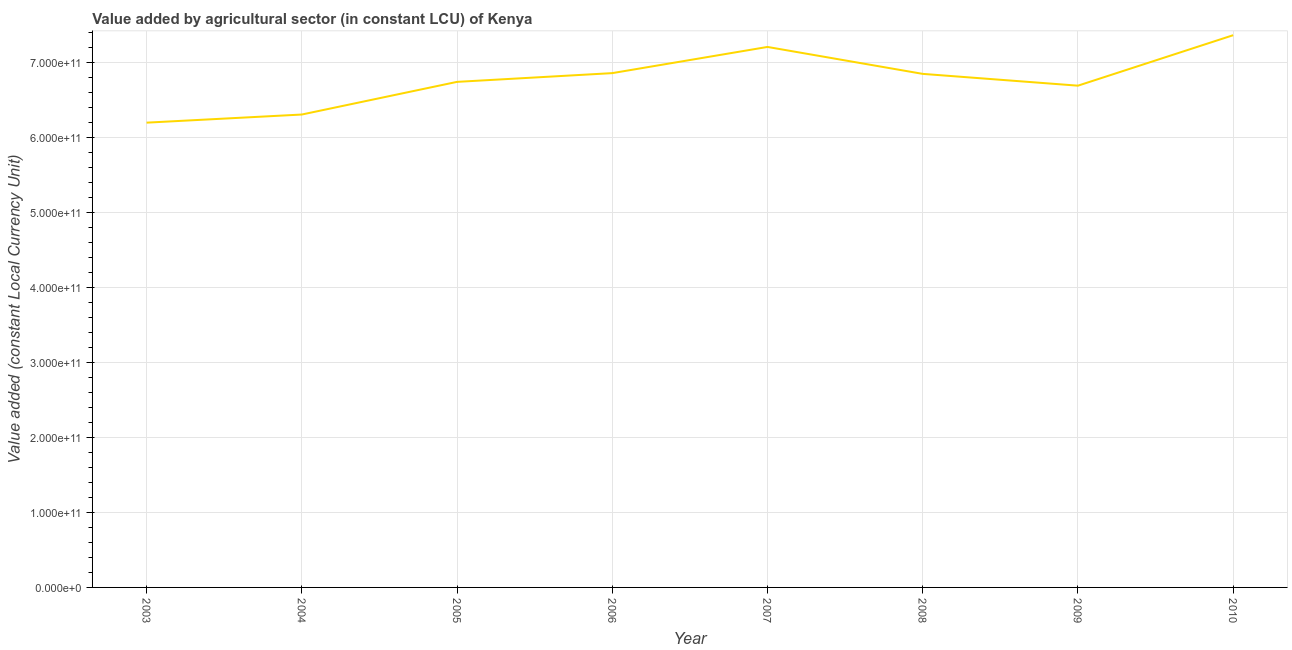What is the value added by agriculture sector in 2004?
Provide a short and direct response. 6.31e+11. Across all years, what is the maximum value added by agriculture sector?
Offer a very short reply. 7.36e+11. Across all years, what is the minimum value added by agriculture sector?
Provide a short and direct response. 6.20e+11. What is the sum of the value added by agriculture sector?
Give a very brief answer. 5.42e+12. What is the difference between the value added by agriculture sector in 2005 and 2008?
Make the answer very short. -1.07e+1. What is the average value added by agriculture sector per year?
Offer a terse response. 6.78e+11. What is the median value added by agriculture sector?
Give a very brief answer. 6.79e+11. What is the ratio of the value added by agriculture sector in 2004 to that in 2010?
Your response must be concise. 0.86. Is the value added by agriculture sector in 2005 less than that in 2007?
Your response must be concise. Yes. Is the difference between the value added by agriculture sector in 2008 and 2010 greater than the difference between any two years?
Keep it short and to the point. No. What is the difference between the highest and the second highest value added by agriculture sector?
Your answer should be very brief. 1.57e+1. What is the difference between the highest and the lowest value added by agriculture sector?
Offer a terse response. 1.17e+11. Does the value added by agriculture sector monotonically increase over the years?
Provide a short and direct response. No. What is the difference between two consecutive major ticks on the Y-axis?
Ensure brevity in your answer.  1.00e+11. What is the title of the graph?
Offer a terse response. Value added by agricultural sector (in constant LCU) of Kenya. What is the label or title of the X-axis?
Ensure brevity in your answer.  Year. What is the label or title of the Y-axis?
Provide a short and direct response. Value added (constant Local Currency Unit). What is the Value added (constant Local Currency Unit) in 2003?
Your answer should be compact. 6.20e+11. What is the Value added (constant Local Currency Unit) in 2004?
Your answer should be compact. 6.31e+11. What is the Value added (constant Local Currency Unit) in 2005?
Give a very brief answer. 6.74e+11. What is the Value added (constant Local Currency Unit) of 2006?
Offer a very short reply. 6.86e+11. What is the Value added (constant Local Currency Unit) of 2007?
Make the answer very short. 7.21e+11. What is the Value added (constant Local Currency Unit) of 2008?
Ensure brevity in your answer.  6.85e+11. What is the Value added (constant Local Currency Unit) in 2009?
Keep it short and to the point. 6.69e+11. What is the Value added (constant Local Currency Unit) of 2010?
Your answer should be compact. 7.36e+11. What is the difference between the Value added (constant Local Currency Unit) in 2003 and 2004?
Your answer should be compact. -1.08e+1. What is the difference between the Value added (constant Local Currency Unit) in 2003 and 2005?
Keep it short and to the point. -5.44e+1. What is the difference between the Value added (constant Local Currency Unit) in 2003 and 2006?
Your answer should be compact. -6.60e+1. What is the difference between the Value added (constant Local Currency Unit) in 2003 and 2007?
Your response must be concise. -1.01e+11. What is the difference between the Value added (constant Local Currency Unit) in 2003 and 2008?
Provide a short and direct response. -6.50e+1. What is the difference between the Value added (constant Local Currency Unit) in 2003 and 2009?
Your answer should be compact. -4.93e+1. What is the difference between the Value added (constant Local Currency Unit) in 2003 and 2010?
Make the answer very short. -1.17e+11. What is the difference between the Value added (constant Local Currency Unit) in 2004 and 2005?
Provide a succinct answer. -4.35e+1. What is the difference between the Value added (constant Local Currency Unit) in 2004 and 2006?
Keep it short and to the point. -5.52e+1. What is the difference between the Value added (constant Local Currency Unit) in 2004 and 2007?
Your answer should be very brief. -9.01e+1. What is the difference between the Value added (constant Local Currency Unit) in 2004 and 2008?
Your response must be concise. -5.42e+1. What is the difference between the Value added (constant Local Currency Unit) in 2004 and 2009?
Provide a succinct answer. -3.85e+1. What is the difference between the Value added (constant Local Currency Unit) in 2004 and 2010?
Your answer should be very brief. -1.06e+11. What is the difference between the Value added (constant Local Currency Unit) in 2005 and 2006?
Ensure brevity in your answer.  -1.17e+1. What is the difference between the Value added (constant Local Currency Unit) in 2005 and 2007?
Your answer should be compact. -4.66e+1. What is the difference between the Value added (constant Local Currency Unit) in 2005 and 2008?
Make the answer very short. -1.07e+1. What is the difference between the Value added (constant Local Currency Unit) in 2005 and 2009?
Ensure brevity in your answer.  5.08e+09. What is the difference between the Value added (constant Local Currency Unit) in 2005 and 2010?
Ensure brevity in your answer.  -6.22e+1. What is the difference between the Value added (constant Local Currency Unit) in 2006 and 2007?
Keep it short and to the point. -3.49e+1. What is the difference between the Value added (constant Local Currency Unit) in 2006 and 2008?
Make the answer very short. 1.01e+09. What is the difference between the Value added (constant Local Currency Unit) in 2006 and 2009?
Your answer should be compact. 1.67e+1. What is the difference between the Value added (constant Local Currency Unit) in 2006 and 2010?
Your answer should be compact. -5.06e+1. What is the difference between the Value added (constant Local Currency Unit) in 2007 and 2008?
Your answer should be compact. 3.59e+1. What is the difference between the Value added (constant Local Currency Unit) in 2007 and 2009?
Your answer should be very brief. 5.16e+1. What is the difference between the Value added (constant Local Currency Unit) in 2007 and 2010?
Offer a terse response. -1.57e+1. What is the difference between the Value added (constant Local Currency Unit) in 2008 and 2009?
Provide a succinct answer. 1.57e+1. What is the difference between the Value added (constant Local Currency Unit) in 2008 and 2010?
Your response must be concise. -5.16e+1. What is the difference between the Value added (constant Local Currency Unit) in 2009 and 2010?
Your response must be concise. -6.73e+1. What is the ratio of the Value added (constant Local Currency Unit) in 2003 to that in 2004?
Your answer should be very brief. 0.98. What is the ratio of the Value added (constant Local Currency Unit) in 2003 to that in 2005?
Your response must be concise. 0.92. What is the ratio of the Value added (constant Local Currency Unit) in 2003 to that in 2006?
Your answer should be very brief. 0.9. What is the ratio of the Value added (constant Local Currency Unit) in 2003 to that in 2007?
Your answer should be very brief. 0.86. What is the ratio of the Value added (constant Local Currency Unit) in 2003 to that in 2008?
Make the answer very short. 0.91. What is the ratio of the Value added (constant Local Currency Unit) in 2003 to that in 2009?
Ensure brevity in your answer.  0.93. What is the ratio of the Value added (constant Local Currency Unit) in 2003 to that in 2010?
Provide a short and direct response. 0.84. What is the ratio of the Value added (constant Local Currency Unit) in 2004 to that in 2005?
Your answer should be compact. 0.94. What is the ratio of the Value added (constant Local Currency Unit) in 2004 to that in 2006?
Offer a terse response. 0.92. What is the ratio of the Value added (constant Local Currency Unit) in 2004 to that in 2008?
Provide a succinct answer. 0.92. What is the ratio of the Value added (constant Local Currency Unit) in 2004 to that in 2009?
Ensure brevity in your answer.  0.94. What is the ratio of the Value added (constant Local Currency Unit) in 2004 to that in 2010?
Provide a succinct answer. 0.86. What is the ratio of the Value added (constant Local Currency Unit) in 2005 to that in 2006?
Ensure brevity in your answer.  0.98. What is the ratio of the Value added (constant Local Currency Unit) in 2005 to that in 2007?
Offer a terse response. 0.94. What is the ratio of the Value added (constant Local Currency Unit) in 2005 to that in 2008?
Your answer should be compact. 0.98. What is the ratio of the Value added (constant Local Currency Unit) in 2005 to that in 2009?
Offer a very short reply. 1.01. What is the ratio of the Value added (constant Local Currency Unit) in 2005 to that in 2010?
Give a very brief answer. 0.92. What is the ratio of the Value added (constant Local Currency Unit) in 2006 to that in 2008?
Provide a short and direct response. 1. What is the ratio of the Value added (constant Local Currency Unit) in 2006 to that in 2009?
Your response must be concise. 1.02. What is the ratio of the Value added (constant Local Currency Unit) in 2006 to that in 2010?
Make the answer very short. 0.93. What is the ratio of the Value added (constant Local Currency Unit) in 2007 to that in 2008?
Ensure brevity in your answer.  1.05. What is the ratio of the Value added (constant Local Currency Unit) in 2007 to that in 2009?
Your response must be concise. 1.08. What is the ratio of the Value added (constant Local Currency Unit) in 2007 to that in 2010?
Your answer should be very brief. 0.98. What is the ratio of the Value added (constant Local Currency Unit) in 2008 to that in 2009?
Provide a succinct answer. 1.02. What is the ratio of the Value added (constant Local Currency Unit) in 2009 to that in 2010?
Offer a very short reply. 0.91. 